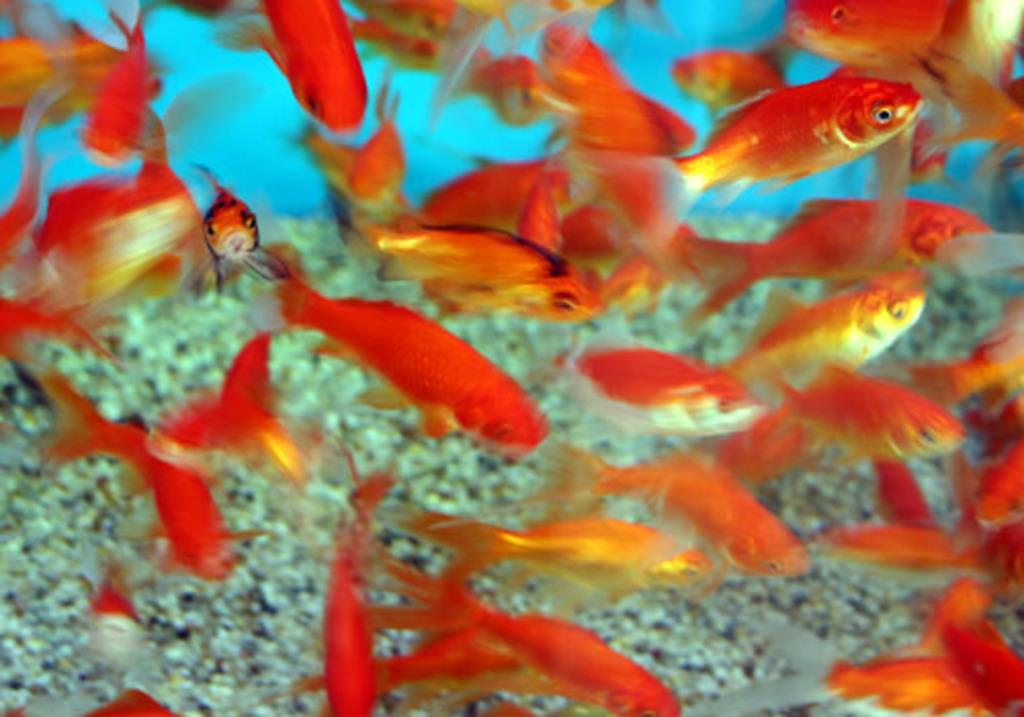What type of animals can be seen in the water in the image? There are golden fishes in the water in the image. What type of terrain is visible in the image? There is sand visible in the image. How many chickens can be seen on the land in the image? There is no land or chickens present in the image; it features golden fishes in the water and sand. What type of reptiles are slithering through the sand in the image? There are no reptiles or snakes present in the image; it features golden fishes in the water and sand. 